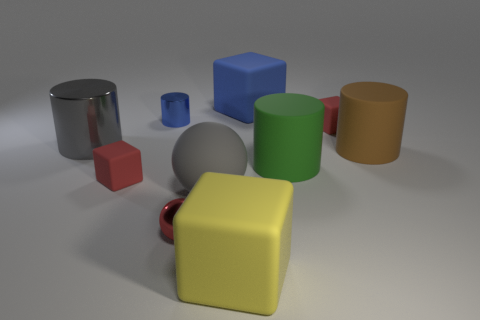Subtract 2 cylinders. How many cylinders are left? 2 Subtract all brown cubes. Subtract all green spheres. How many cubes are left? 4 Subtract 2 red cubes. How many objects are left? 8 Subtract all cylinders. How many objects are left? 6 Subtract all small matte cylinders. Subtract all gray spheres. How many objects are left? 9 Add 9 large green matte things. How many large green matte things are left? 10 Add 6 big red metallic balls. How many big red metallic balls exist? 6 